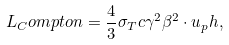<formula> <loc_0><loc_0><loc_500><loc_500>L _ { C } o m p t o n = \frac { 4 } { 3 } \sigma _ { T } c \gamma ^ { 2 } \beta ^ { 2 } \cdot u _ { p } h ,</formula> 